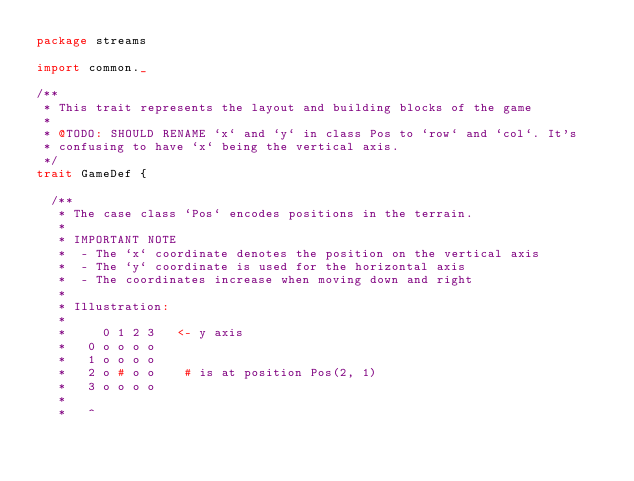Convert code to text. <code><loc_0><loc_0><loc_500><loc_500><_Scala_>package streams

import common._

/**
 * This trait represents the layout and building blocks of the game
 *
 * @TODO: SHOULD RENAME `x` and `y` in class Pos to `row` and `col`. It's
 * confusing to have `x` being the vertical axis.
 */
trait GameDef {

  /**
   * The case class `Pos` encodes positions in the terrain.
   * 
   * IMPORTANT NOTE
   *  - The `x` coordinate denotes the position on the vertical axis
   *  - The `y` coordinate is used for the horizontal axis
   *  - The coordinates increase when moving down and right
   * 
   * Illustration:
   *
   *     0 1 2 3   <- y axis
   *   0 o o o o
   *   1 o o o o
   *   2 o # o o    # is at position Pos(2, 1)
   *   3 o o o o
   *  
   *   ^</code> 